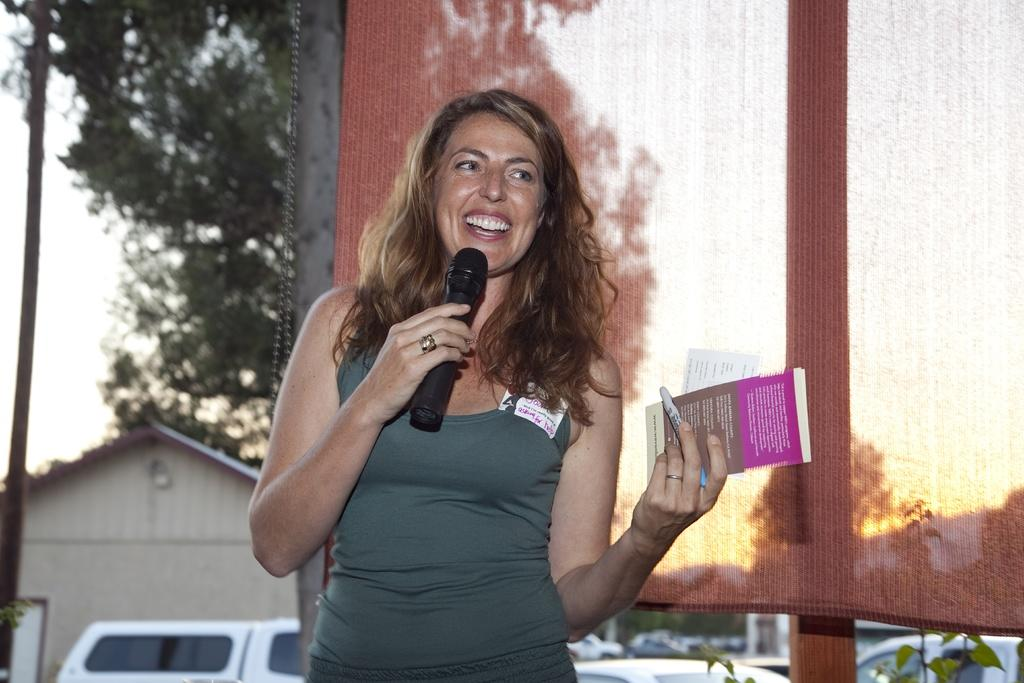What is the main subject of the image? The main subject of the image is a woman. What is the woman doing in the image? The woman is standing and holding a microphone in one hand and a book in the other hand. What is the woman holding along with the book? The woman is holding a pen in her hand along with the book. What type of balloon is floating above the woman's head in the image? There is no balloon present in the image. What is the plot of the story the woman is reading from the book in the image? The image does not provide enough information to determine the plot of the story in the book. 